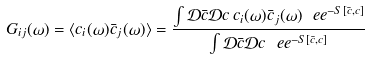<formula> <loc_0><loc_0><loc_500><loc_500>G _ { i j } ( \omega ) = \langle c _ { i } ( \omega ) \bar { c } _ { j } ( \omega ) \rangle = \frac { \int { \mathcal { D } } \bar { c } { \mathcal { D } } { c } \, c _ { i } ( \omega ) \bar { c } _ { j } ( \omega ) \ e e ^ { - S [ \bar { c } , c ] } } { \int { \mathcal { D } } \bar { c } { \mathcal { D } } { c } \ e e ^ { - S [ \bar { c } , c ] } }</formula> 